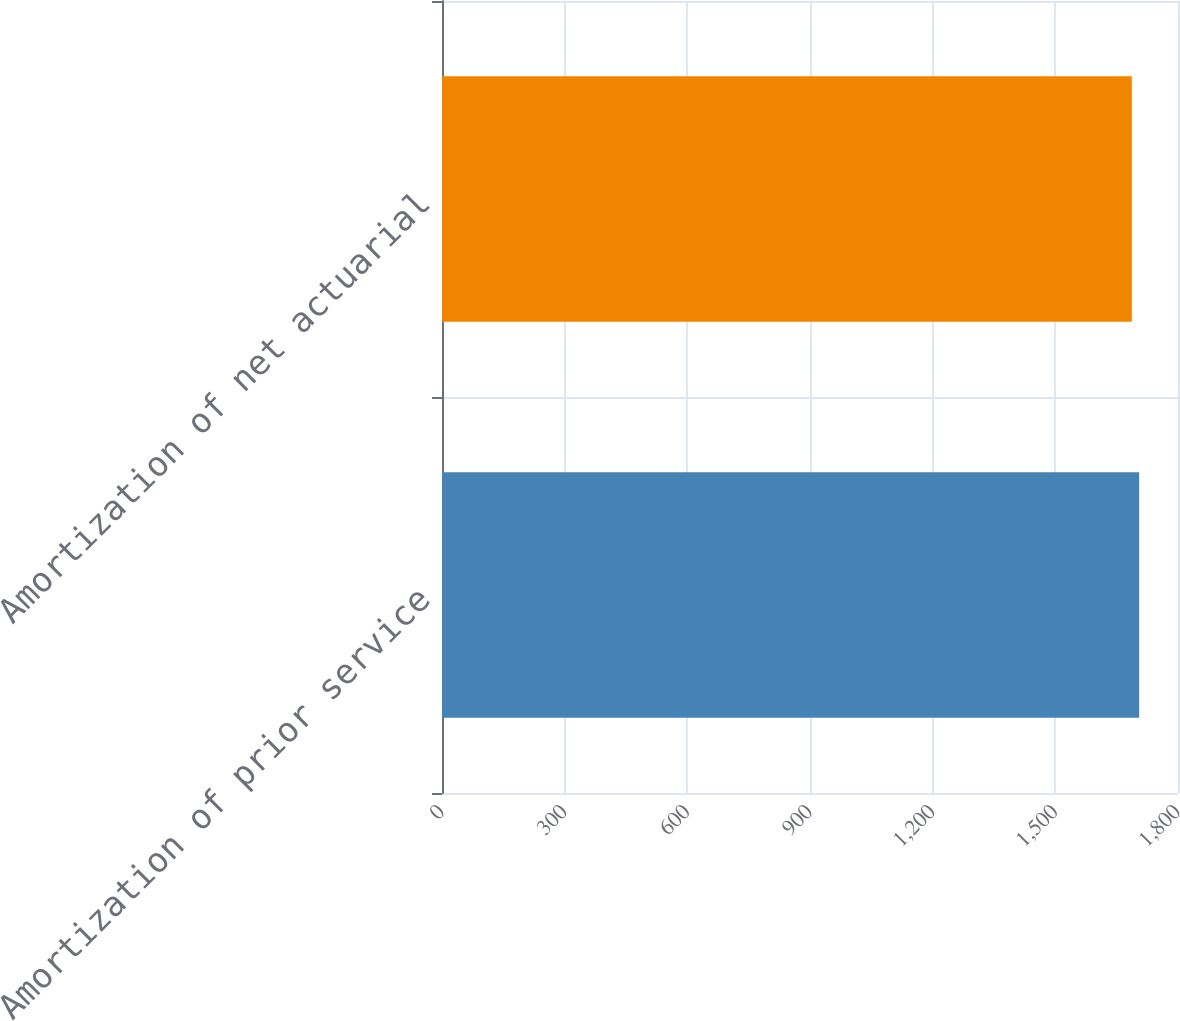Convert chart. <chart><loc_0><loc_0><loc_500><loc_500><bar_chart><fcel>Amortization of prior service<fcel>Amortization of net actuarial<nl><fcel>1705<fcel>1687<nl></chart> 